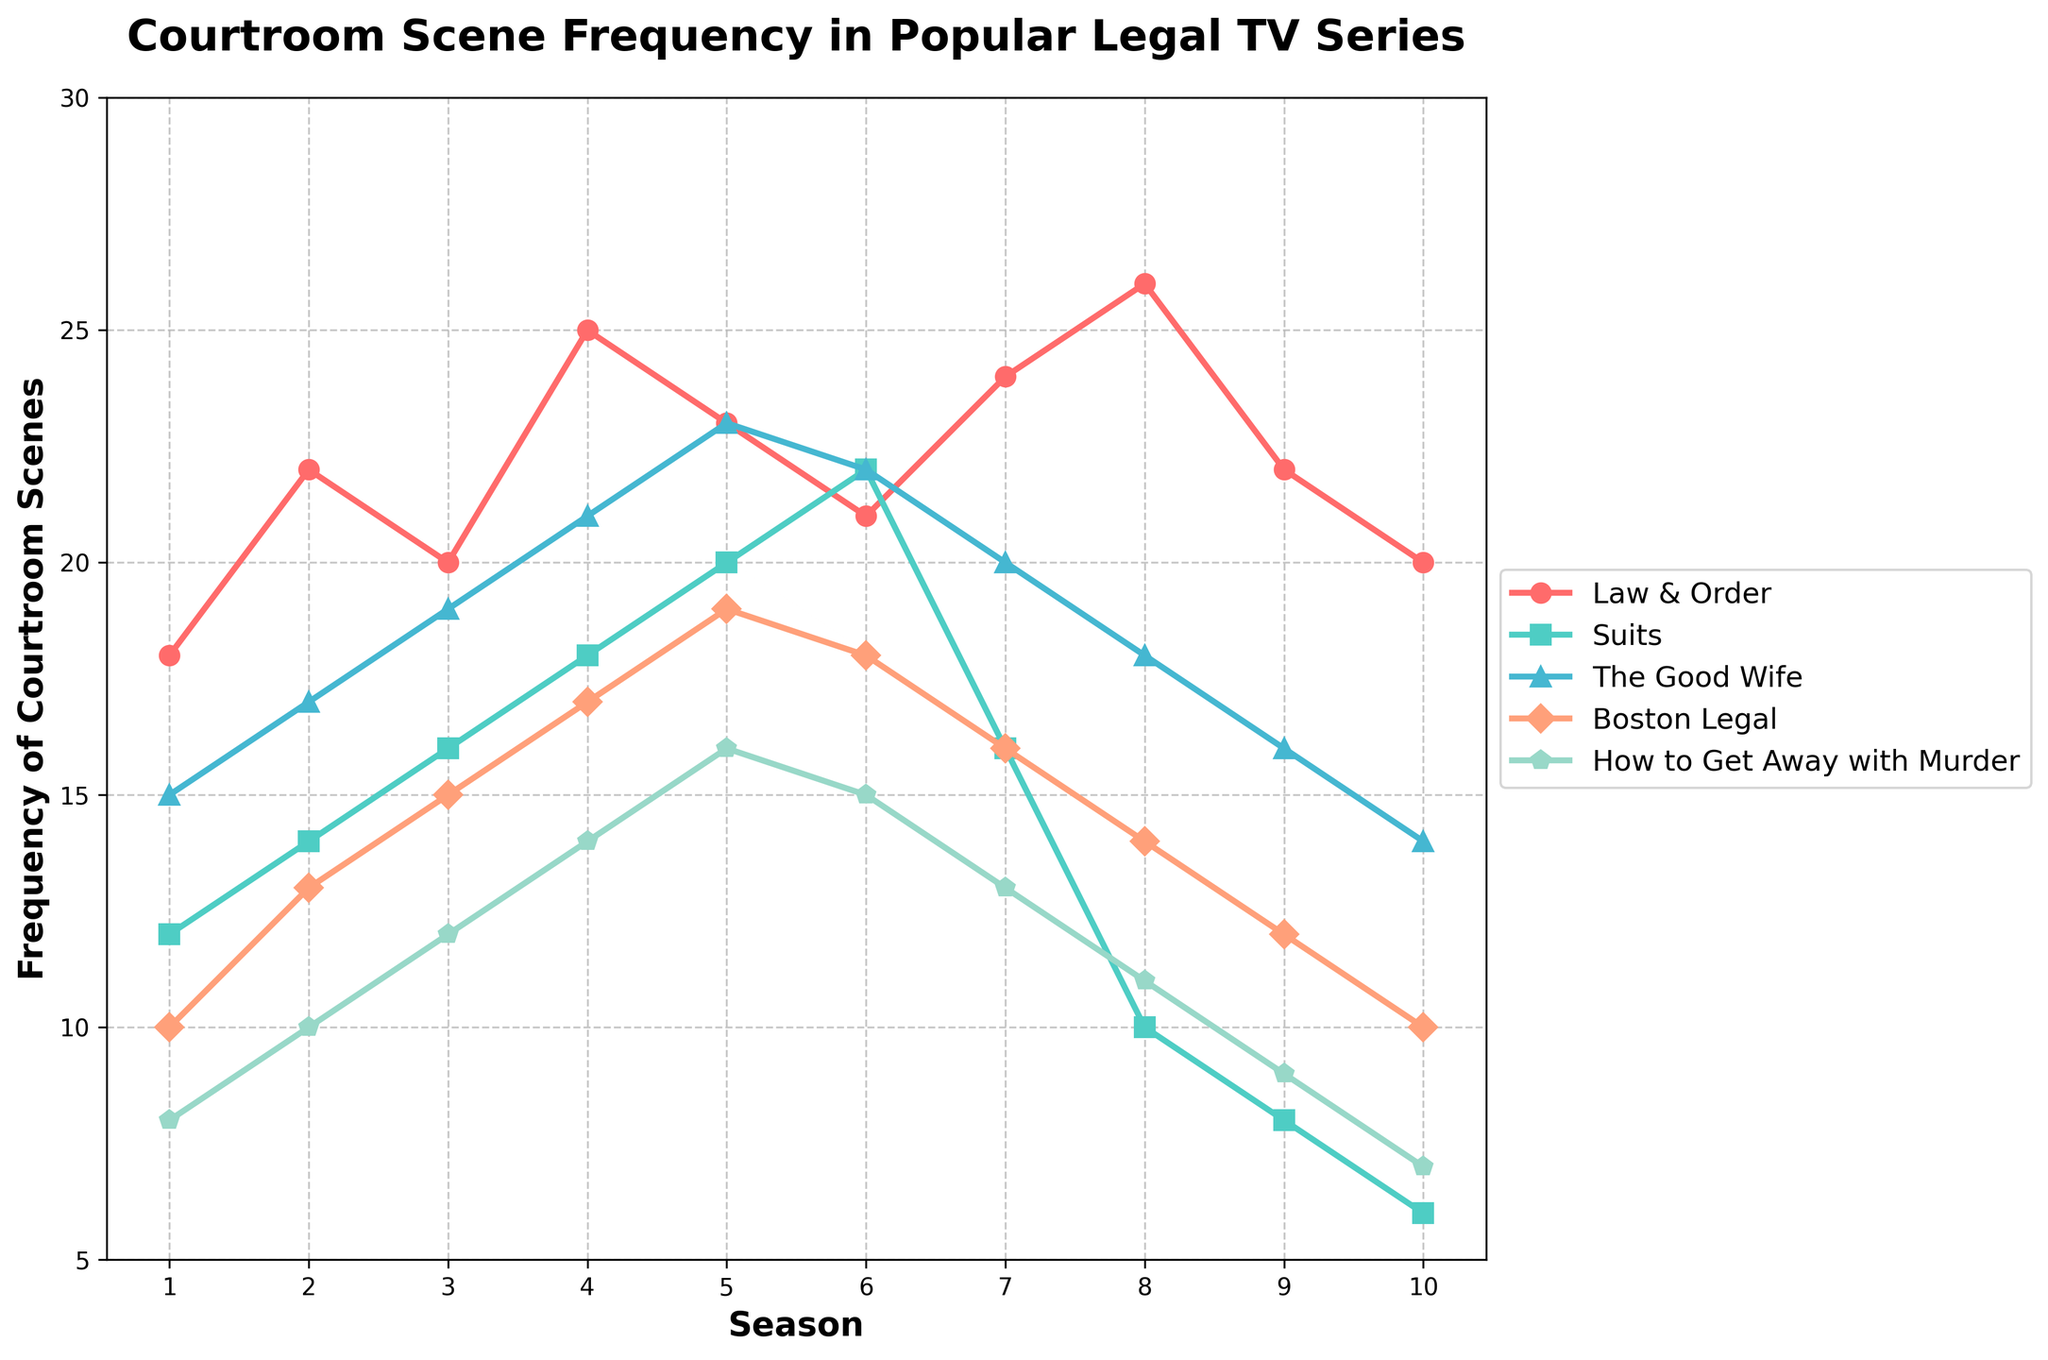What is the average frequency of courtroom scenes for "Law & Order" across all seasons? Sum the frequencies of "Law & Order" across all seasons: 18+22+20+25+23+21+24+26+22+20 = 221. The total number of seasons is 10. The average is 221/10.
Answer: 22.1 In Season 5, which show had the highest frequency of courtroom scenes? The frequencies for Season 5 are: "Law & Order" - 23, "Suits" - 20, "The Good Wife" - 23, "Boston Legal" - 19, "How to Get Away with Murder" - 16. The highest value is 23.
Answer: Law & Order and The Good Wife By how much did the frequency of courtroom scenes increase for "Suits" from Season 1 to Season 6? The frequency in Season 1 is 12 and in Season 6 is 22. The difference is 22 - 12.
Answer: 10 Which show had the most consistent frequency of courtroom scenes across all seasons, and what visual attribute indicates this? The visual attribute to consider is the smoothness of the line. "The Good Wife" shows the least fluctuation in its values across all seasons, as its line does not have large jumps.
Answer: The Good Wife In which season did "How to Get Away with Murder" experience its highest frequency of courtroom scenes? Check the frequencies for "How to Get Away with Murder" across all seasons. The highest value is in Season 6 with 16 scenes.
Answer: Season 6 Which two shows have intersecting lines at any season and what season is that? By visually tracing the plotted lines, "Law & Order" and "The Good Wife" intersect in Season 5 where both have a frequency of 23.
Answer: Law & Order and The Good Wife; Season 5 By what percentage did "Boston Legal's" courtroom scenes increase from Season 1 to Season 4? Season 1 (10) to Season 4 (17). The difference is 17 - 10 = 7. Percentage increase is (7/10) * 100.
Answer: 70% 